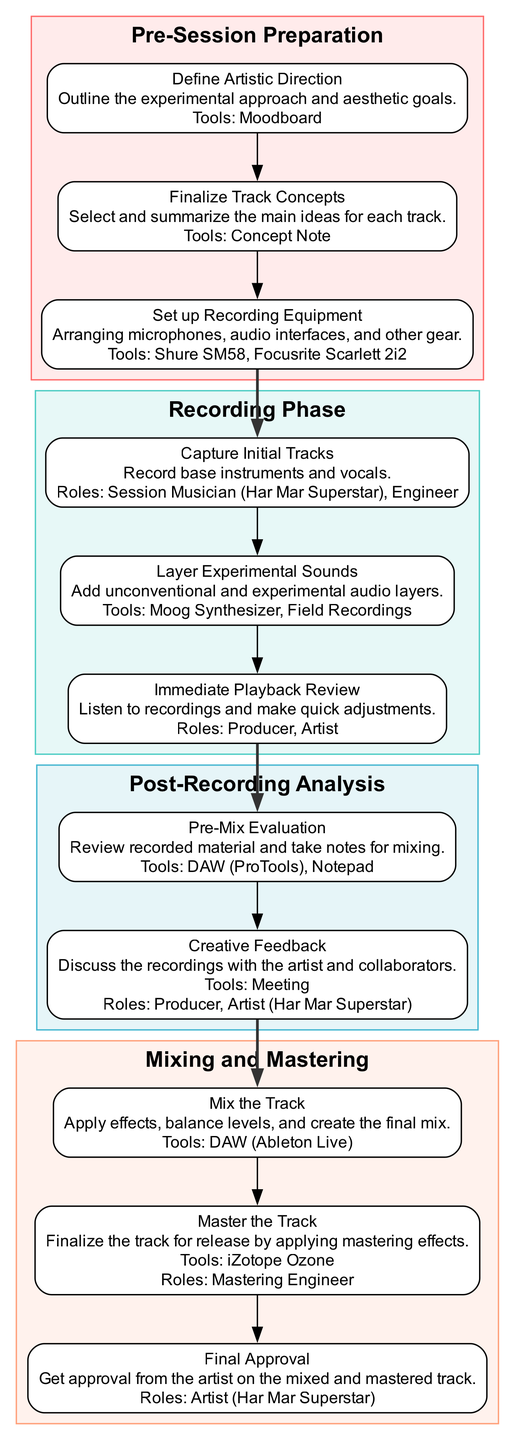What is the first step in the Pre-Session Preparation phase? The first step listed in the Pre-Session Preparation phase is "Define Artistic Direction," which outlines the experimental approach and aesthetic goals.
Answer: Define Artistic Direction How many steps are in the Recording Phase? The Recording Phase contains three steps: "Capture Initial Tracks," "Layer Experimental Sounds," and "Immediate Playback Review."
Answer: 3 What tool is used for Pre-Mix Evaluation? The tool used for Pre-Mix Evaluation is a "DAW (ProTools)" along with "Notepad" for taking notes on the recorded material.
Answer: DAW (ProTools) Which role is involved during the Immediate Playback Review? The roles involved during the Immediate Playback Review are "Producer" and "Artist."
Answer: Producer, Artist What is the last step in the Mixing and Mastering phase? The last step in the Mixing and Mastering phase is "Final Approval," which requires getting approval from the artist on the mixed and mastered track.
Answer: Final Approval How do you transition from the Recording Phase to Post-Recording Analysis? To transition from the Recording Phase to Post-Recording Analysis, the last step of the Recording Phase, "Immediate Playback Review," connects to the first step of the Post-Recording Analysis, which is "Pre-Mix Evaluation."
Answer: Immediate Playback Review to Pre-Mix Evaluation Which phase follows Post-Recording Analysis? The phase that follows Post-Recording Analysis is "Mixing and Mastering."
Answer: Mixing and Mastering What describes the relationship between "Layer Experimental Sounds" and "Pre-Mix Evaluation"? The relationship is sequential; "Layer Experimental Sounds" is part of the Recording Phase, and it leads directly to the "Pre-Mix Evaluation" in the next phase (Post-Recording Analysis).
Answer: Sequential relationship 